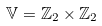<formula> <loc_0><loc_0><loc_500><loc_500>\mathbb { V } = \mathbb { Z } _ { 2 } \times \mathbb { Z } _ { 2 }</formula> 